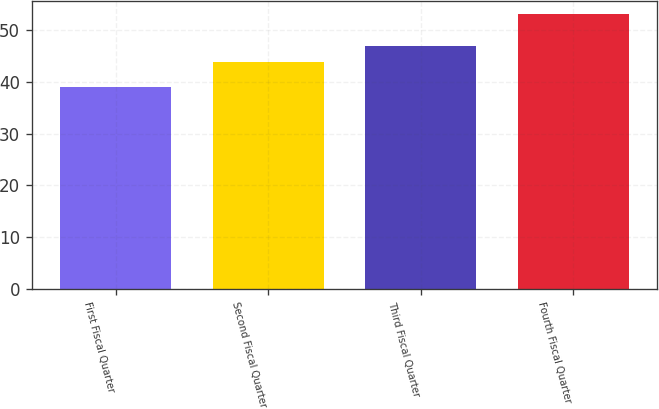Convert chart to OTSL. <chart><loc_0><loc_0><loc_500><loc_500><bar_chart><fcel>First Fiscal Quarter<fcel>Second Fiscal Quarter<fcel>Third Fiscal Quarter<fcel>Fourth Fiscal Quarter<nl><fcel>39.05<fcel>43.85<fcel>46.97<fcel>53.09<nl></chart> 